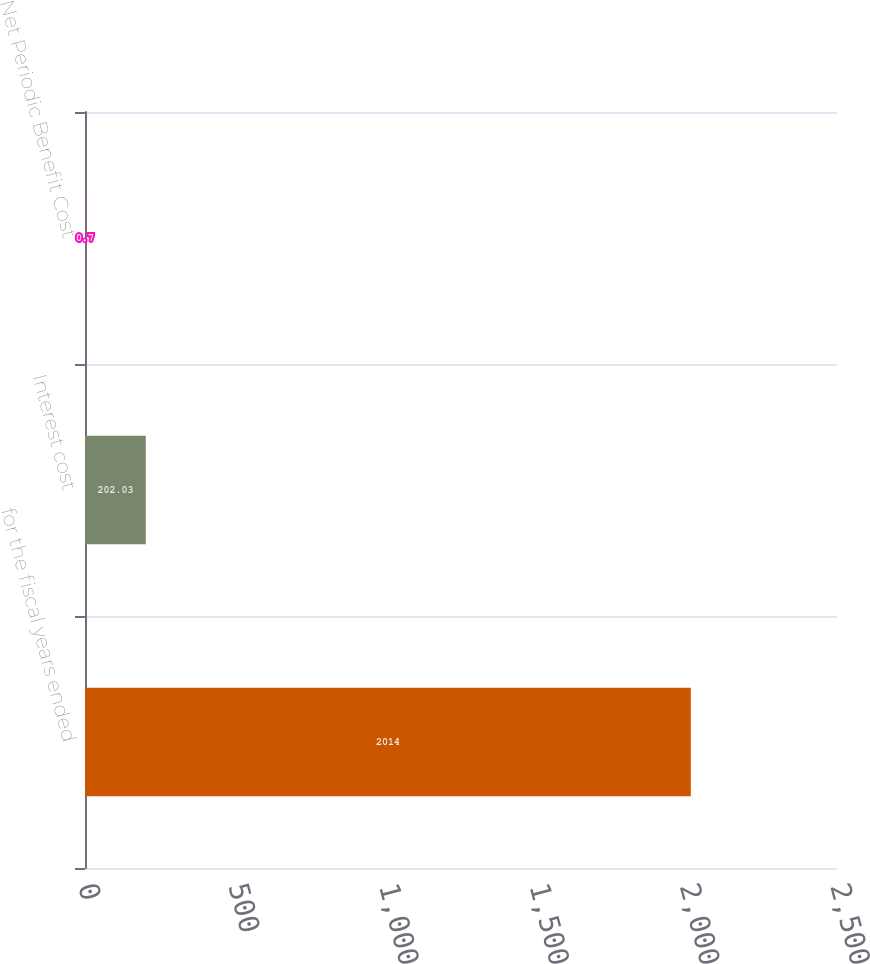<chart> <loc_0><loc_0><loc_500><loc_500><bar_chart><fcel>for the fiscal years ended<fcel>Interest cost<fcel>Net Periodic Benefit Cost<nl><fcel>2014<fcel>202.03<fcel>0.7<nl></chart> 